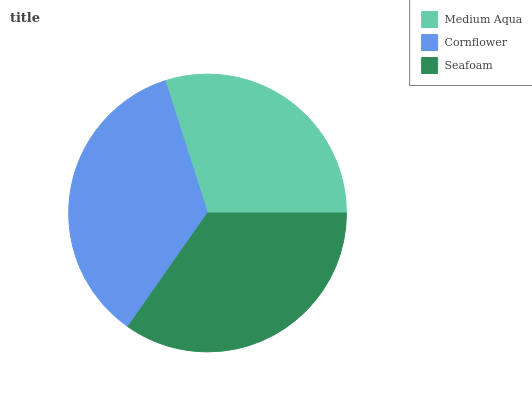Is Medium Aqua the minimum?
Answer yes or no. Yes. Is Cornflower the maximum?
Answer yes or no. Yes. Is Seafoam the minimum?
Answer yes or no. No. Is Seafoam the maximum?
Answer yes or no. No. Is Cornflower greater than Seafoam?
Answer yes or no. Yes. Is Seafoam less than Cornflower?
Answer yes or no. Yes. Is Seafoam greater than Cornflower?
Answer yes or no. No. Is Cornflower less than Seafoam?
Answer yes or no. No. Is Seafoam the high median?
Answer yes or no. Yes. Is Seafoam the low median?
Answer yes or no. Yes. Is Medium Aqua the high median?
Answer yes or no. No. Is Medium Aqua the low median?
Answer yes or no. No. 